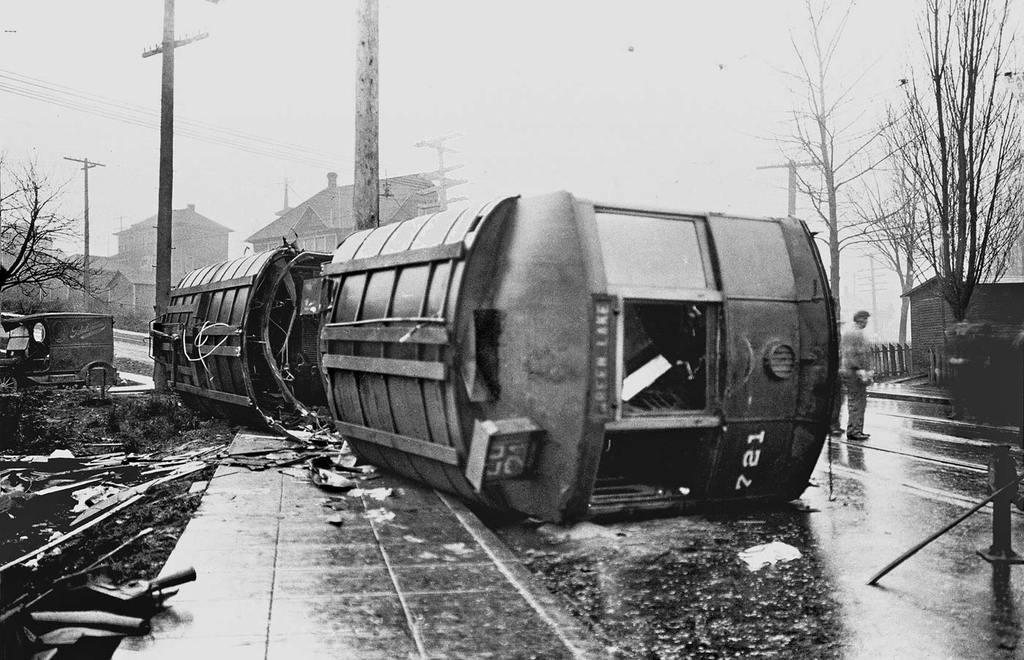What is the color scheme of the image? The image is black and white. What can be seen on the road in the image? There is a person standing on the road. What type of vegetation is visible in the image? Grass and trees are present in the image. What type of structures can be seen in the image? Buildings are visible in the image. What else is present in the image besides the person, vegetation, and buildings? Poles and some objects are present in the image. What is visible in the background of the image? The sky is visible in the background. Can you tell me how many strangers the person in the image is talking to? There is no indication of any strangers or conversations in the image. 